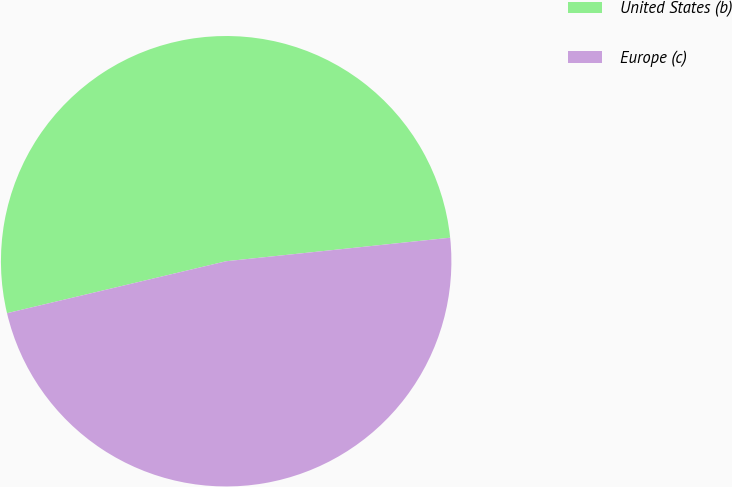<chart> <loc_0><loc_0><loc_500><loc_500><pie_chart><fcel>United States (b)<fcel>Europe (c)<nl><fcel>52.04%<fcel>47.96%<nl></chart> 